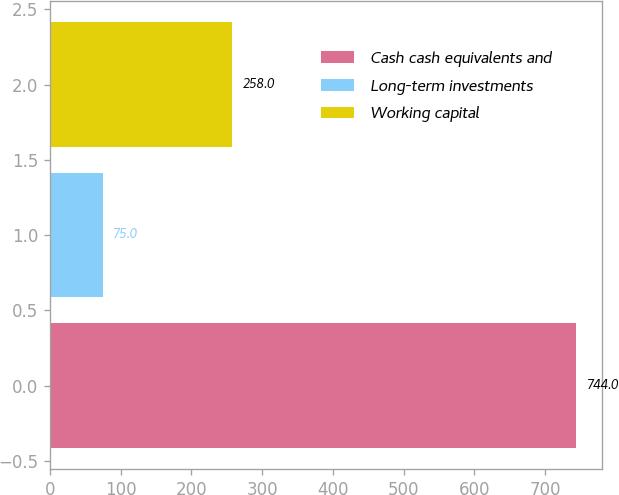Convert chart to OTSL. <chart><loc_0><loc_0><loc_500><loc_500><bar_chart><fcel>Cash cash equivalents and<fcel>Long-term investments<fcel>Working capital<nl><fcel>744<fcel>75<fcel>258<nl></chart> 